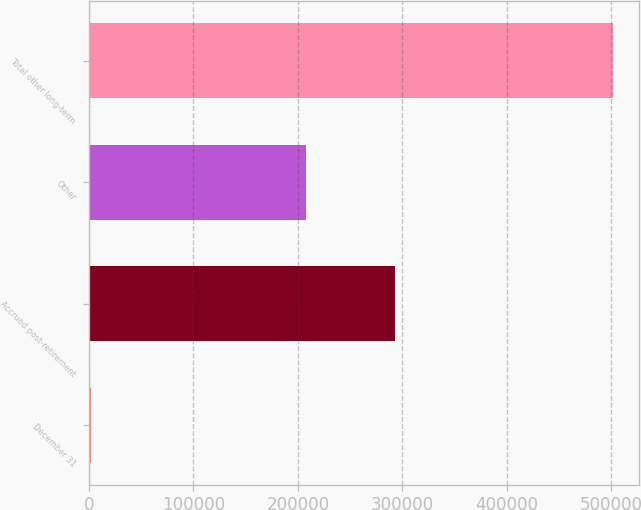<chart> <loc_0><loc_0><loc_500><loc_500><bar_chart><fcel>December 31<fcel>Accrued post-retirement<fcel>Other<fcel>Total other long-term<nl><fcel>2009<fcel>293273<fcel>208061<fcel>501334<nl></chart> 